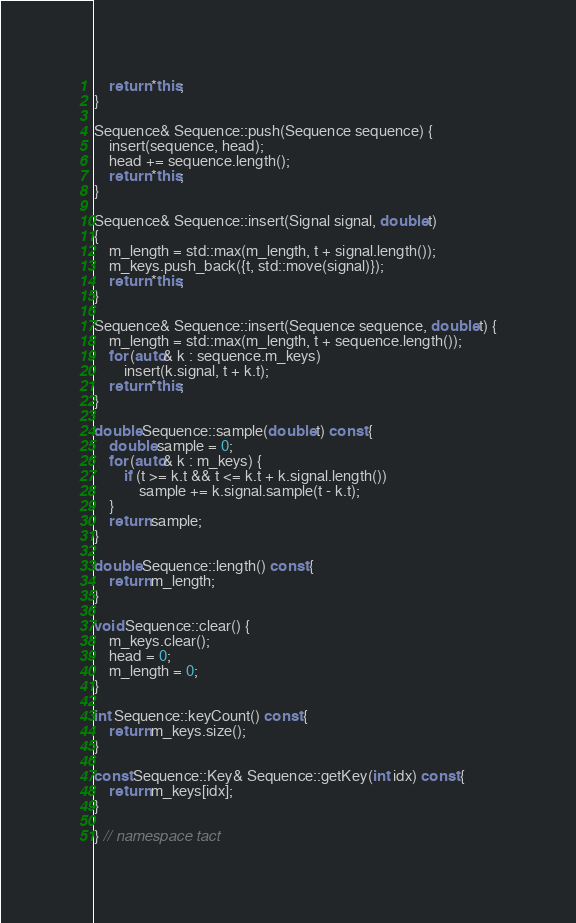<code> <loc_0><loc_0><loc_500><loc_500><_C++_>    return *this;
}

Sequence& Sequence::push(Sequence sequence) {
    insert(sequence, head);
    head += sequence.length();
    return *this;
}

Sequence& Sequence::insert(Signal signal, double t) 
{
    m_length = std::max(m_length, t + signal.length());
    m_keys.push_back({t, std::move(signal)});
    return *this;
}

Sequence& Sequence::insert(Sequence sequence, double t) {
    m_length = std::max(m_length, t + sequence.length());
    for (auto& k : sequence.m_keys)
        insert(k.signal, t + k.t);
    return *this;
}

double Sequence::sample(double t) const {
    double sample = 0;
    for (auto& k : m_keys) {
        if (t >= k.t && t <= k.t + k.signal.length())
            sample += k.signal.sample(t - k.t);
    }
    return sample;
}

double Sequence::length() const {
    return m_length;
}

void Sequence::clear() {
    m_keys.clear();
    head = 0;
    m_length = 0;
}

int Sequence::keyCount() const {
    return m_keys.size();
}

const Sequence::Key& Sequence::getKey(int idx) const {
    return m_keys[idx];
}

} // namespace tact</code> 